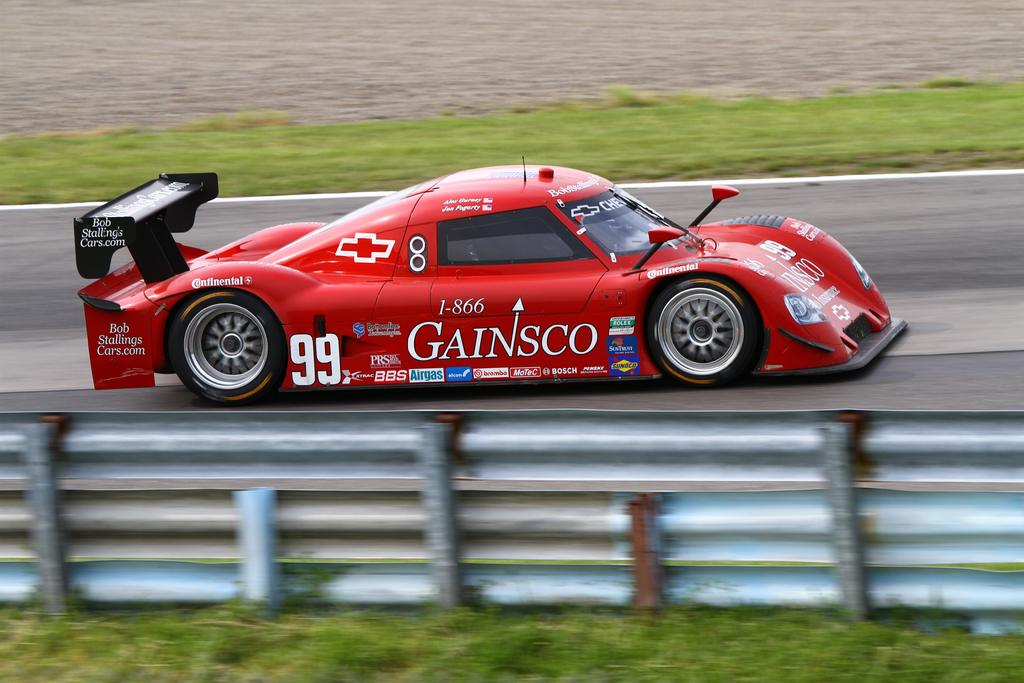What type of barrier can be seen in the image? There is a fence in the image. What is located on the road in the image? There is a vehicle on the road in the image. What type of vegetation is visible on the ground in the background of the image? There is grass visible on the ground in the background of the image. What type of stew is being prepared in the image? There is no stew present in the image. What type of tank can be seen in the image? There is no tank present in the image. 